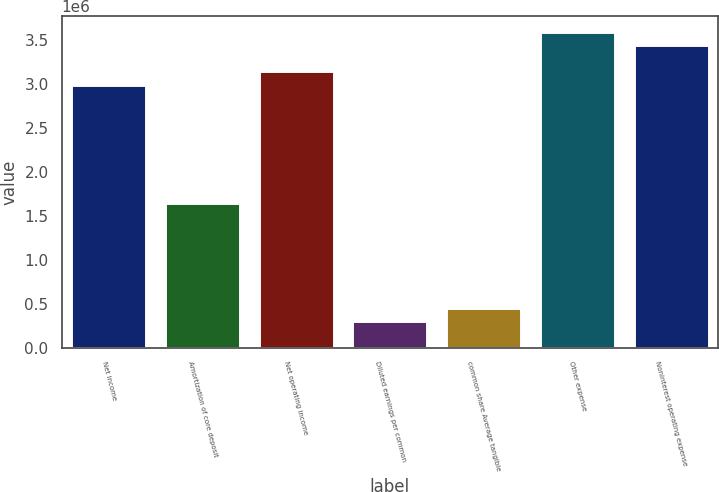Convert chart to OTSL. <chart><loc_0><loc_0><loc_500><loc_500><bar_chart><fcel>Net income<fcel>Amortization of core deposit<fcel>Net operating income<fcel>Diluted earnings per common<fcel>common share Average tangible<fcel>Other expense<fcel>Noninterest operating expense<nl><fcel>2.99496e+06<fcel>1.64723e+06<fcel>3.14471e+06<fcel>299496<fcel>449244<fcel>3.59395e+06<fcel>3.4442e+06<nl></chart> 